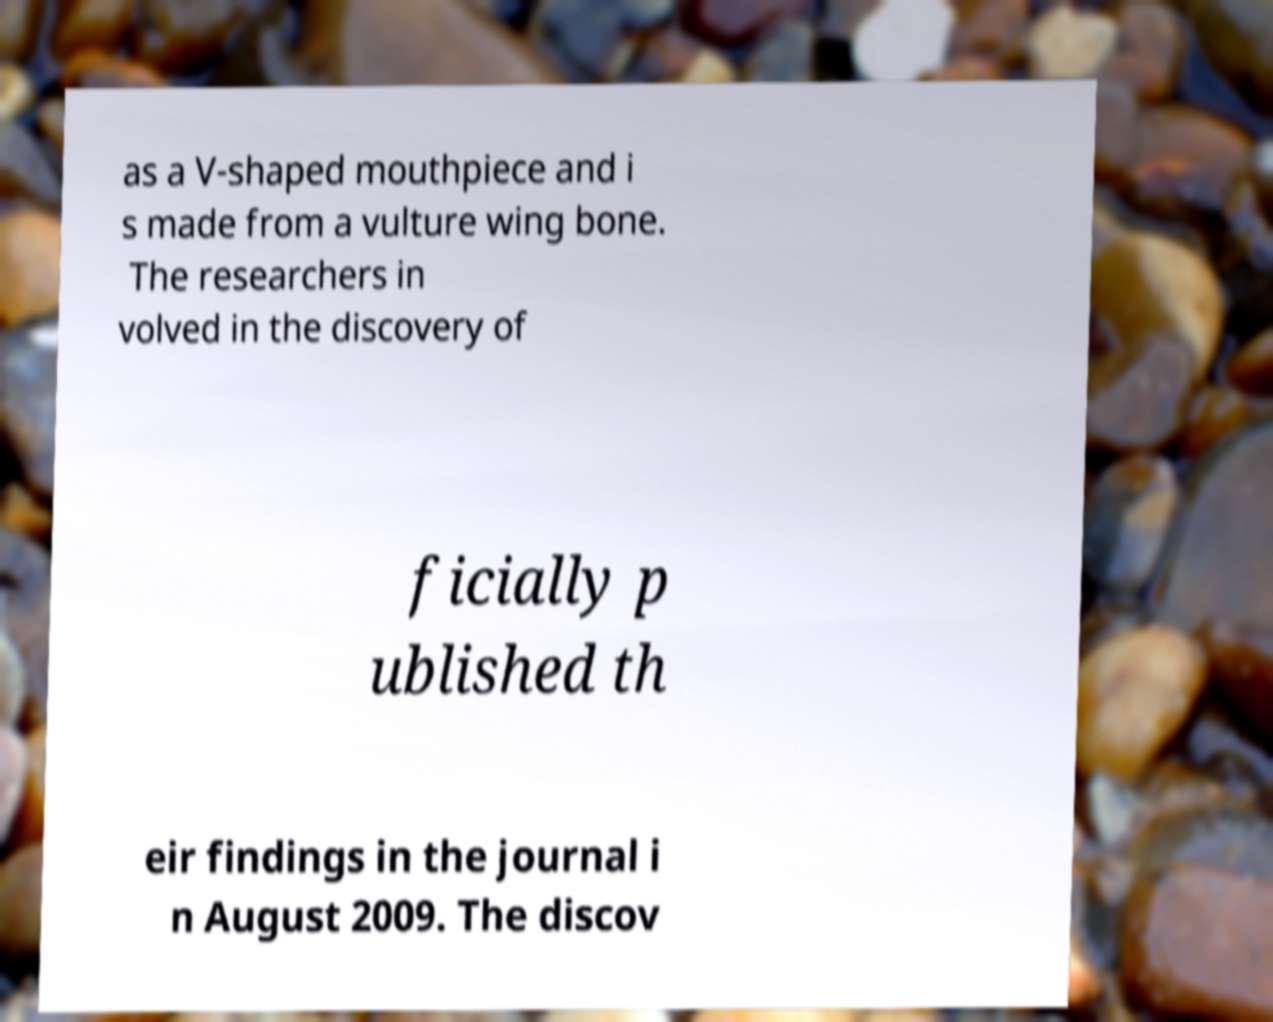What messages or text are displayed in this image? I need them in a readable, typed format. as a V-shaped mouthpiece and i s made from a vulture wing bone. The researchers in volved in the discovery of ficially p ublished th eir findings in the journal i n August 2009. The discov 